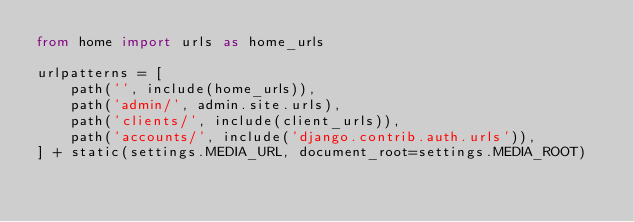<code> <loc_0><loc_0><loc_500><loc_500><_Python_>from home import urls as home_urls

urlpatterns = [
    path('', include(home_urls)),
    path('admin/', admin.site.urls),
    path('clients/', include(client_urls)),
    path('accounts/', include('django.contrib.auth.urls')),
] + static(settings.MEDIA_URL, document_root=settings.MEDIA_ROOT)
</code> 